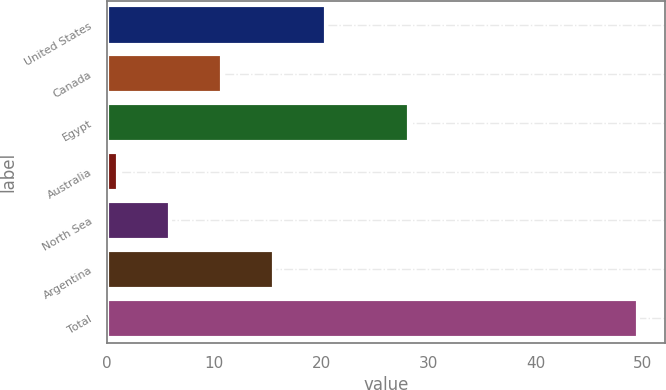<chart> <loc_0><loc_0><loc_500><loc_500><bar_chart><fcel>United States<fcel>Canada<fcel>Egypt<fcel>Australia<fcel>North Sea<fcel>Argentina<fcel>Total<nl><fcel>20.44<fcel>10.72<fcel>28.2<fcel>1<fcel>5.86<fcel>15.58<fcel>49.6<nl></chart> 